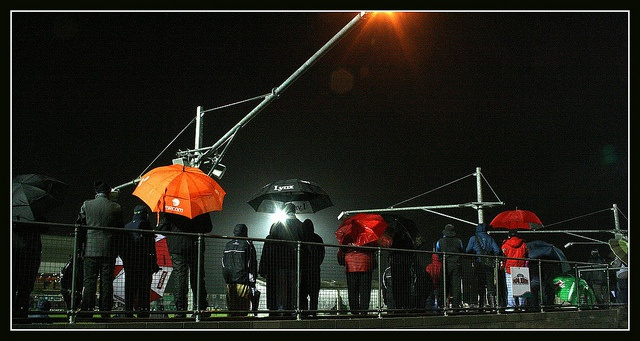Describe the objects in this image and their specific colors. I can see people in black, gray, darkgreen, and blue tones, people in black, gray, and darkgreen tones, umbrella in black, red, orange, and brown tones, people in black and gray tones, and people in black, gray, darkgray, and darkgreen tones in this image. 